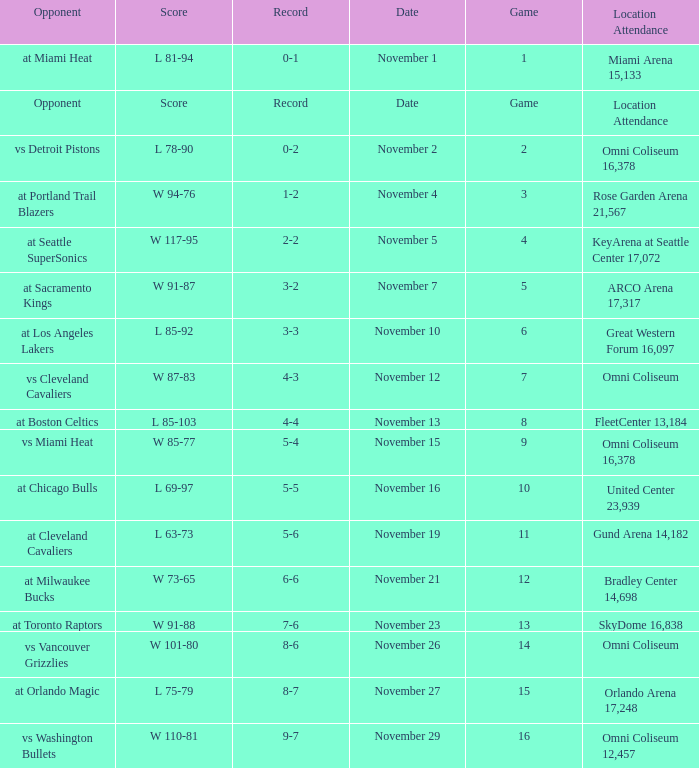On what date was game 3? November 4. 